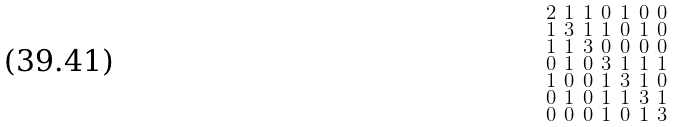Convert formula to latex. <formula><loc_0><loc_0><loc_500><loc_500>\begin{smallmatrix} 2 & 1 & 1 & 0 & 1 & 0 & 0 \\ 1 & 3 & 1 & 1 & 0 & 1 & 0 \\ 1 & 1 & 3 & 0 & 0 & 0 & 0 \\ 0 & 1 & 0 & 3 & 1 & 1 & 1 \\ 1 & 0 & 0 & 1 & 3 & 1 & 0 \\ 0 & 1 & 0 & 1 & 1 & 3 & 1 \\ 0 & 0 & 0 & 1 & 0 & 1 & 3 \end{smallmatrix}</formula> 